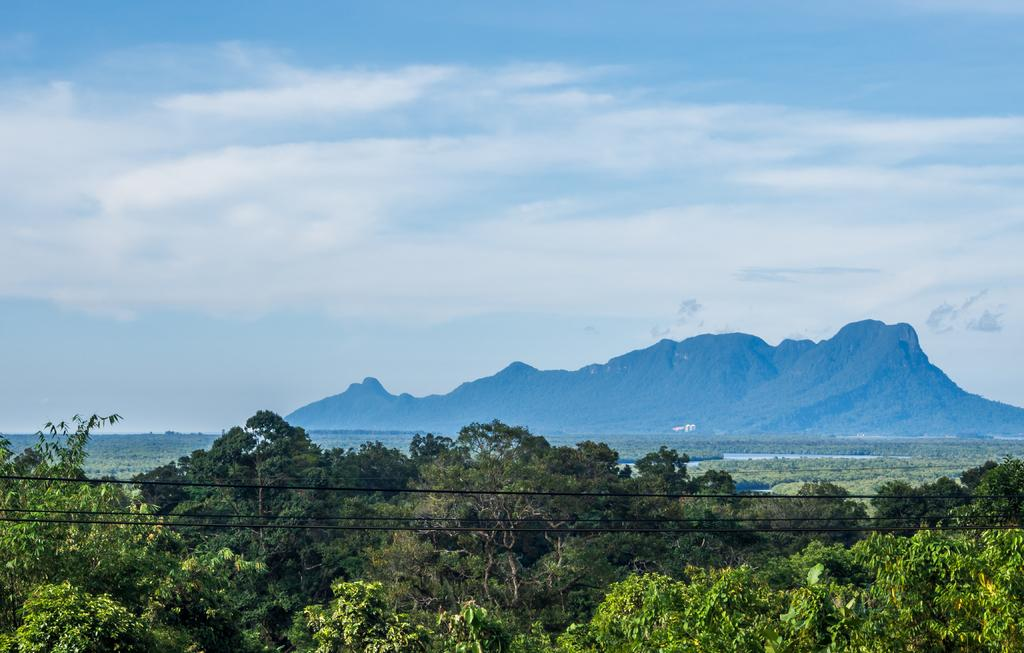What is present in the image that is related to electrical connections? There are wires in the image. What type of natural elements can be seen in the image? There are trees in the image. What geographical feature is visible in the background of the image? There is a hill visible in the background of the image. What is visible in the sky in the image? The sky is visible in the background of the image, and clouds are present in it. What type of glass can be seen in the image? There is no glass present in the image. What is the taste of the clouds in the image? Clouds do not have a taste, and there is no indication of any taste-related elements in the image. 